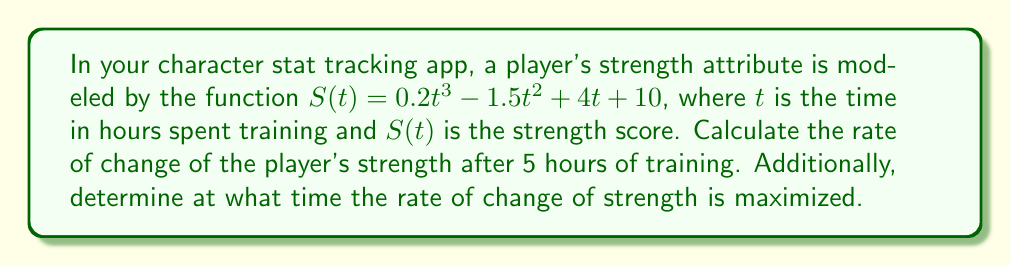Show me your answer to this math problem. To solve this problem, we need to use derivatives to analyze the rate of change of the strength attribute.

1. First, let's find the derivative of the strength function $S(t)$:
   $$S'(t) = \frac{d}{dt}(0.2t^3 - 1.5t^2 + 4t + 10)$$
   $$S'(t) = 0.6t^2 - 3t + 4$$

   This derivative represents the instantaneous rate of change of strength with respect to time.

2. To find the rate of change after 5 hours of training, we evaluate $S'(t)$ at $t = 5$:
   $$S'(5) = 0.6(5^2) - 3(5) + 4$$
   $$S'(5) = 0.6(25) - 15 + 4$$
   $$S'(5) = 15 - 15 + 4 = 4$$

3. To determine when the rate of change is maximized, we need to find the maximum of $S'(t)$. This occurs when the derivative of $S'(t)$ equals zero:
   $$\frac{d}{dt}S'(t) = \frac{d}{dt}(0.6t^2 - 3t + 4) = 1.2t - 3$$

   Set this equal to zero and solve for $t$:
   $$1.2t - 3 = 0$$
   $$1.2t = 3$$
   $$t = \frac{3}{1.2} = 2.5$$

   To confirm this is a maximum (not a minimum), we can check that the second derivative is negative at this point:
   $$\frac{d^2}{dt^2}S'(t) = 1.2 > 0$$

   Since the second derivative is positive, $t = 2.5$ actually gives us a minimum rate of change.

   The maximum rate of change occurs at the endpoints of the domain. Since time cannot be negative, the maximum rate of change occurs as $t$ approaches infinity.
Answer: The rate of change of the player's strength after 5 hours of training is 4 units per hour. The rate of change of strength increases without bound as time increases, so there is no finite time at which it is maximized. 